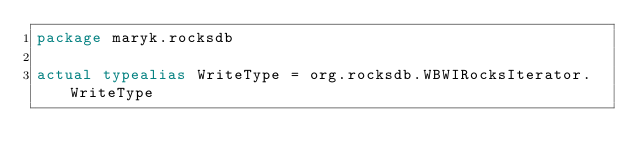<code> <loc_0><loc_0><loc_500><loc_500><_Kotlin_>package maryk.rocksdb

actual typealias WriteType = org.rocksdb.WBWIRocksIterator.WriteType
</code> 